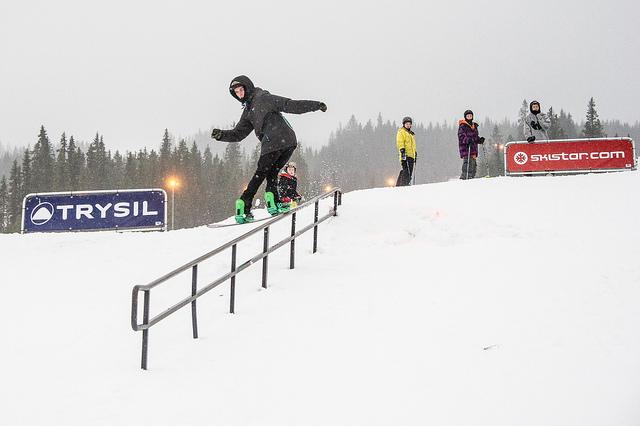What is written on the red sign?
Give a very brief answer. Historycom. What is the snowboarder doing on the handrail?
Keep it brief. Grinding. What color is the brightest color jacket?
Be succinct. Yellow. 